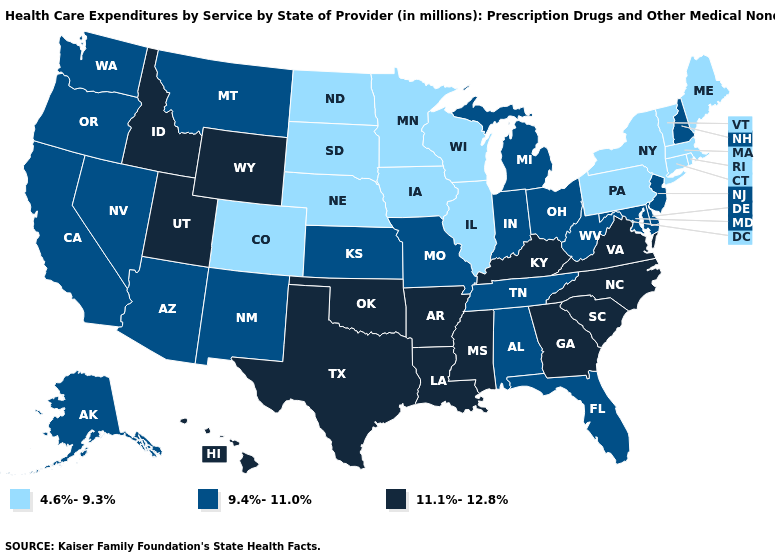Name the states that have a value in the range 4.6%-9.3%?
Write a very short answer. Colorado, Connecticut, Illinois, Iowa, Maine, Massachusetts, Minnesota, Nebraska, New York, North Dakota, Pennsylvania, Rhode Island, South Dakota, Vermont, Wisconsin. Does Arkansas have the same value as Minnesota?
Write a very short answer. No. What is the highest value in the South ?
Concise answer only. 11.1%-12.8%. What is the value of Alaska?
Be succinct. 9.4%-11.0%. Name the states that have a value in the range 9.4%-11.0%?
Quick response, please. Alabama, Alaska, Arizona, California, Delaware, Florida, Indiana, Kansas, Maryland, Michigan, Missouri, Montana, Nevada, New Hampshire, New Jersey, New Mexico, Ohio, Oregon, Tennessee, Washington, West Virginia. What is the highest value in the USA?
Be succinct. 11.1%-12.8%. Among the states that border Missouri , which have the highest value?
Give a very brief answer. Arkansas, Kentucky, Oklahoma. What is the value of Florida?
Quick response, please. 9.4%-11.0%. Name the states that have a value in the range 9.4%-11.0%?
Concise answer only. Alabama, Alaska, Arizona, California, Delaware, Florida, Indiana, Kansas, Maryland, Michigan, Missouri, Montana, Nevada, New Hampshire, New Jersey, New Mexico, Ohio, Oregon, Tennessee, Washington, West Virginia. Does Arkansas have the same value as Virginia?
Be succinct. Yes. Does Wisconsin have the same value as Pennsylvania?
Short answer required. Yes. Does the map have missing data?
Give a very brief answer. No. What is the highest value in the USA?
Be succinct. 11.1%-12.8%. Name the states that have a value in the range 4.6%-9.3%?
Keep it brief. Colorado, Connecticut, Illinois, Iowa, Maine, Massachusetts, Minnesota, Nebraska, New York, North Dakota, Pennsylvania, Rhode Island, South Dakota, Vermont, Wisconsin. What is the value of North Dakota?
Write a very short answer. 4.6%-9.3%. 